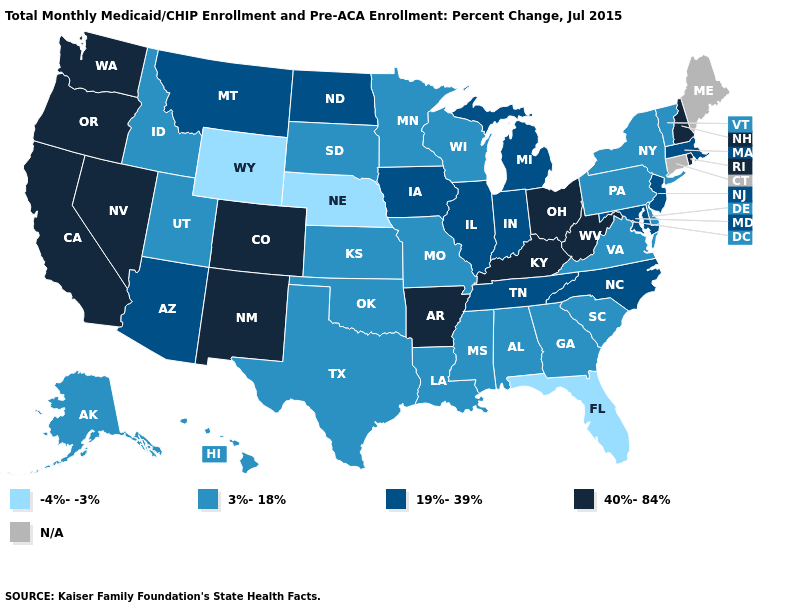What is the lowest value in states that border Rhode Island?
Concise answer only. 19%-39%. Name the states that have a value in the range N/A?
Write a very short answer. Connecticut, Maine. Name the states that have a value in the range -4%--3%?
Concise answer only. Florida, Nebraska, Wyoming. What is the value of Montana?
Short answer required. 19%-39%. Among the states that border North Carolina , which have the lowest value?
Short answer required. Georgia, South Carolina, Virginia. Which states have the lowest value in the USA?
Quick response, please. Florida, Nebraska, Wyoming. Does Missouri have the highest value in the USA?
Concise answer only. No. What is the value of Louisiana?
Write a very short answer. 3%-18%. Name the states that have a value in the range 3%-18%?
Quick response, please. Alabama, Alaska, Delaware, Georgia, Hawaii, Idaho, Kansas, Louisiana, Minnesota, Mississippi, Missouri, New York, Oklahoma, Pennsylvania, South Carolina, South Dakota, Texas, Utah, Vermont, Virginia, Wisconsin. What is the lowest value in states that border Michigan?
Short answer required. 3%-18%. What is the value of Missouri?
Keep it brief. 3%-18%. What is the lowest value in states that border Florida?
Short answer required. 3%-18%. Does the map have missing data?
Be succinct. Yes. What is the value of North Carolina?
Keep it brief. 19%-39%. Among the states that border Nebraska , does Missouri have the lowest value?
Be succinct. No. 